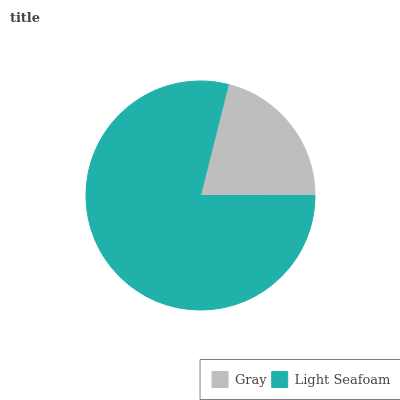Is Gray the minimum?
Answer yes or no. Yes. Is Light Seafoam the maximum?
Answer yes or no. Yes. Is Light Seafoam the minimum?
Answer yes or no. No. Is Light Seafoam greater than Gray?
Answer yes or no. Yes. Is Gray less than Light Seafoam?
Answer yes or no. Yes. Is Gray greater than Light Seafoam?
Answer yes or no. No. Is Light Seafoam less than Gray?
Answer yes or no. No. Is Light Seafoam the high median?
Answer yes or no. Yes. Is Gray the low median?
Answer yes or no. Yes. Is Gray the high median?
Answer yes or no. No. Is Light Seafoam the low median?
Answer yes or no. No. 